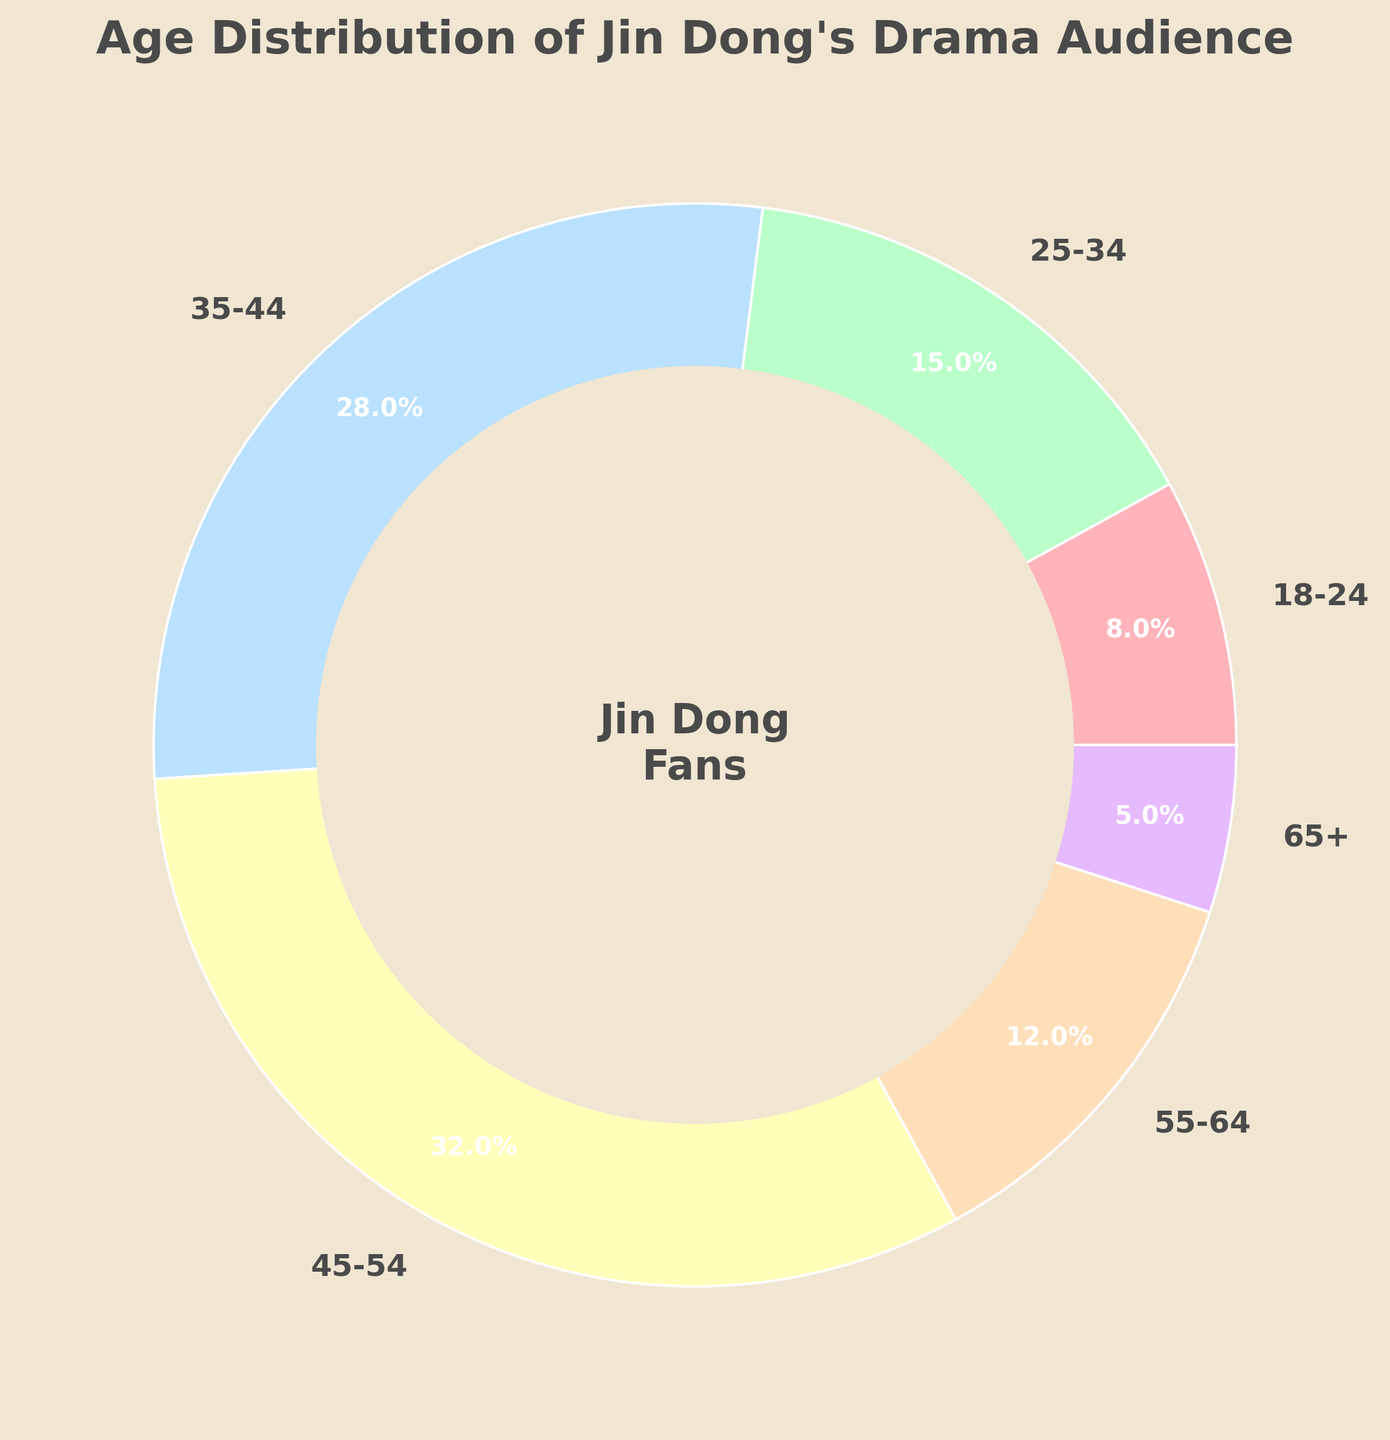What's the largest age group watching Jin Dong's drama? The figure shows a pie chart with age groups and their corresponding percentages. The largest wedge of the pie chart, labeled "45-54," contains 32%.
Answer: 45-54 What's the smallest age group watching Jin Dong's drama? The pie chart shows different age groups and their percentages. The smallest wedge on the chart, labeled "65+," contains 5%.
Answer: 65+ How many age groups have more than 10% of the audience? Observing the pie chart, the age groups "25-34," "35-44," "45-54," and "55-64" have percentages more than 10%. That's a total of four groups.
Answer: 4 What's the combined percentage of the 18-24 and 65+ age groups? The 18-24 group has 8% and the 65+ group has 5%. Summing these up: 8 + 5 = 13%.
Answer: 13% What is the percentage difference between the 35-44 and 25-34 age groups? The 35-44 age group has 28% and the 25-34 age group has 15%. The difference between them is 28 - 15 = 13%.
Answer: 13% Which age group occupies the blue-colored wedge in the pie chart? The image shows different colored wedges. The blue-colored wedge corresponds to the 35-44 age group, labeled as 28%.
Answer: 35-44 How does the percentage of the 55-64 age group compare to that of the 18-24 age group? The 55-64 age group has 12%, while the 18-24 age group has 8%. Since 12% is greater than 8%, the 55-64 age group has a larger percentage than the 18-24 age group.
Answer: 55-64 > 18-24 What's the middle value (median) of the percentages of all age groups? First, order the percentages: 5, 8, 12, 15, 28, 32. The middle values are 12 and 15. The median is the average of these two: (12 + 15) / 2 = 13.5.
Answer: 13.5% Which age group has a yellow-colored wedge? By observing the chart, the light-yellow wedge corresponds to the age group labeled "55-64," which is 12%.
Answer: 55-64 